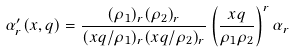Convert formula to latex. <formula><loc_0><loc_0><loc_500><loc_500>\alpha ^ { \prime } _ { r } ( x , q ) = \frac { ( \rho _ { 1 } ) _ { r } ( \rho _ { 2 } ) _ { r } } { ( x q / \rho _ { 1 } ) _ { r } ( x q / \rho _ { 2 } ) _ { r } } \left ( \frac { x q } { \rho _ { 1 } \rho _ { 2 } } \right ) ^ { r } \alpha _ { r }</formula> 